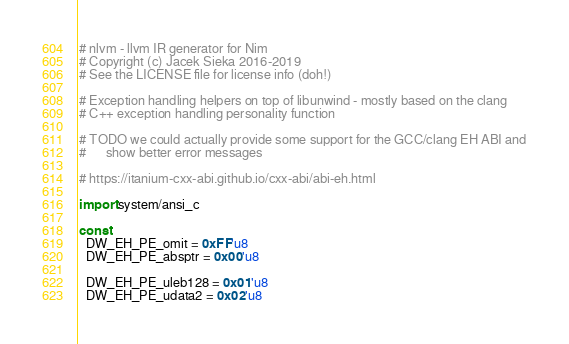<code> <loc_0><loc_0><loc_500><loc_500><_Nim_># nlvm - llvm IR generator for Nim
# Copyright (c) Jacek Sieka 2016-2019
# See the LICENSE file for license info (doh!)

# Exception handling helpers on top of libunwind - mostly based on the clang
# C++ exception handling personality function

# TODO we could actually provide some support for the GCC/clang EH ABI and
#      show better error messages

# https://itanium-cxx-abi.github.io/cxx-abi/abi-eh.html

import system/ansi_c

const
  DW_EH_PE_omit = 0xFF'u8
  DW_EH_PE_absptr = 0x00'u8

  DW_EH_PE_uleb128 = 0x01'u8
  DW_EH_PE_udata2 = 0x02'u8</code> 